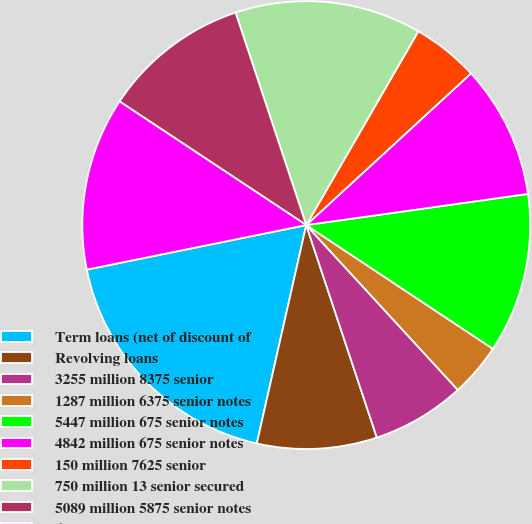<chart> <loc_0><loc_0><loc_500><loc_500><pie_chart><fcel>Term loans (net of discount of<fcel>Revolving loans<fcel>3255 million 8375 senior<fcel>1287 million 6375 senior notes<fcel>5447 million 675 senior notes<fcel>4842 million 675 senior notes<fcel>150 million 7625 senior<fcel>750 million 13 senior secured<fcel>5089 million 5875 senior notes<fcel>650 million 10375 senior<nl><fcel>18.27%<fcel>8.65%<fcel>6.73%<fcel>3.85%<fcel>11.54%<fcel>9.62%<fcel>4.81%<fcel>13.46%<fcel>10.58%<fcel>12.5%<nl></chart> 